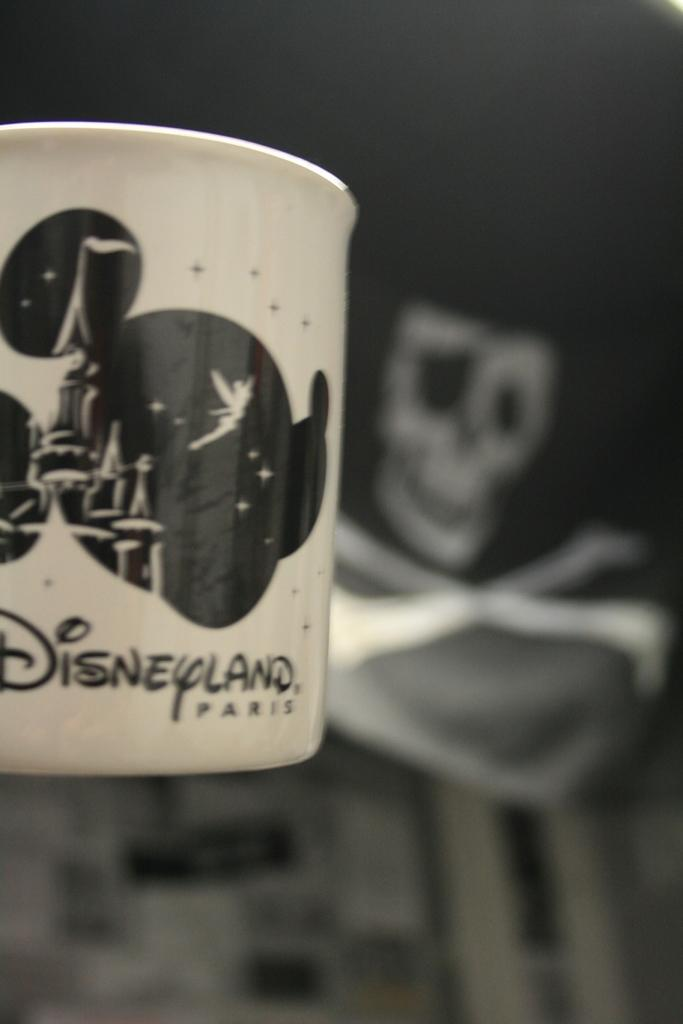<image>
Relay a brief, clear account of the picture shown. A Disneyland cup with a skull in the background 